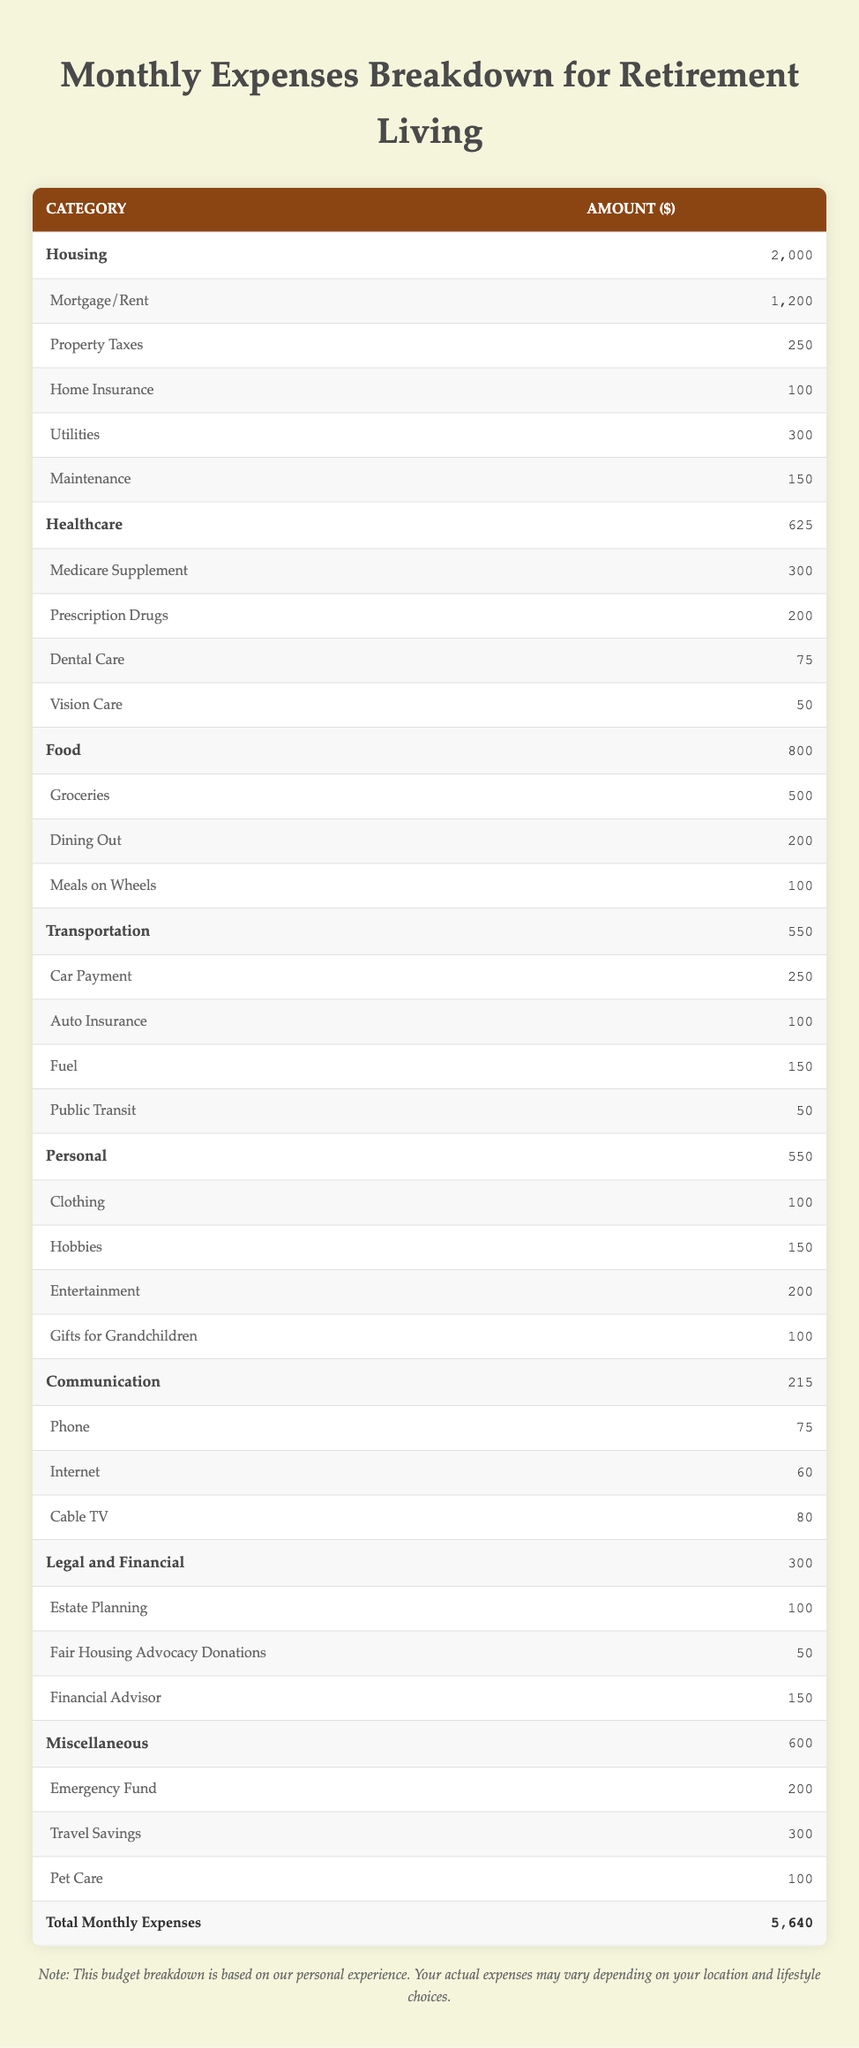What is the total amount spent on Housing? To find the total for Housing, I add the amounts from its subcategories: Mortgage/Rent (1200) + Property Taxes (250) + Home Insurance (100) + Utilities (300) + Maintenance (150) = 2000.
Answer: 2000 How much is spent on Healthcare compared to Food? The amount spent on Healthcare is 625 and on Food is 800. To compare, we notice 800 (Food) - 625 (Healthcare) = 175, indicating that Food expenses are higher by this amount.
Answer: 175 What is the cost of Auto Insurance? The Auto Insurance amount is listed directly in the table as 100.
Answer: 100 Is the amount spent on Communication more than 200? The amount spent on Communication is 215, which is greater than 200. Therefore, the statement is true.
Answer: Yes What is the total amount allocated for Personal expenses? To find the total for Personal expenses, I add the amounts from its subcategories: Clothing (100) + Hobbies (150) + Entertainment (200) + Gifts for Grandchildren (100) = 550.
Answer: 550 What is the average monthly expense across all categories? To find the average, first, I sum the total monthly expenses from the table, which is 5640. There are 7 categories, so the average is 5640 / 7 = 805.71 (rounded to 805.71).
Answer: 805.71 How much is allocated for Emergency Fund compared to Gifts for Grandchildren? Emergency Fund is 200, and Gifts for Grandchildren is 100. Comparing these, we find that 200 (Emergency Fund) - 100 (Gifts for Grandchildren) = 100.
Answer: 100 Is the sum of Transportation expenses greater than 500? Transportation expenses total 550. Since 550 is greater than 500, the statement is true.
Answer: Yes What is the combined total for Legal and Financial categories? To find the combined total, I add the amounts in the Legal and Financial category: Estate Planning (100) + Fair Housing Advocacy Donations (50) + Financial Advisor (150) = 300.
Answer: 300 